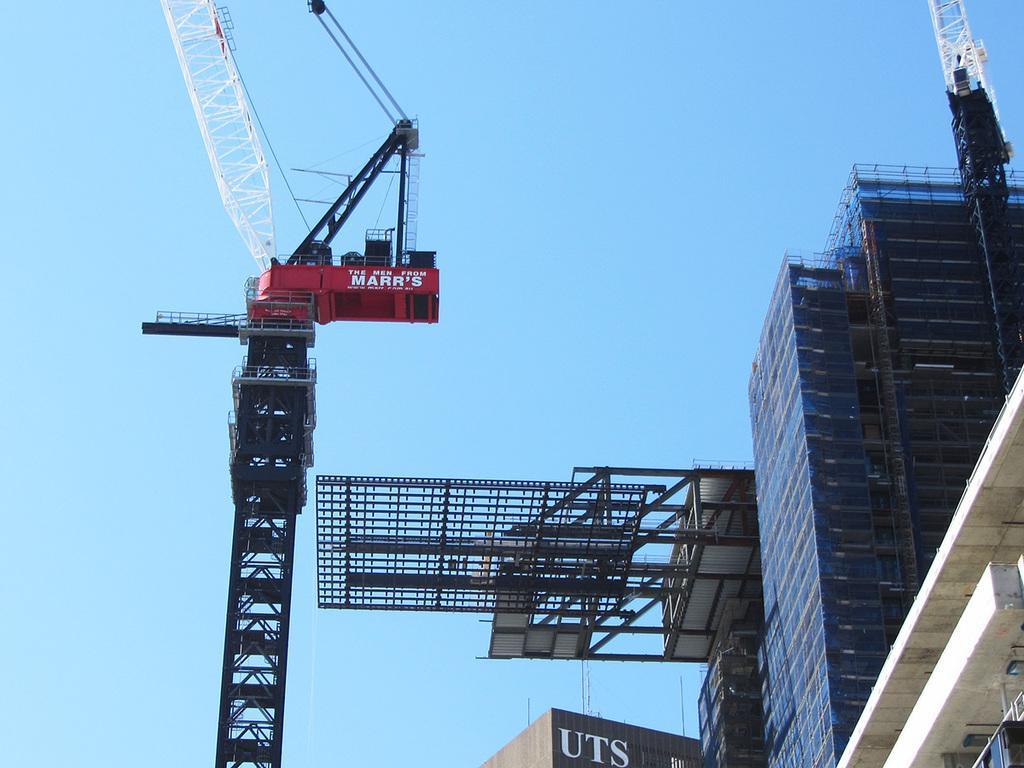Describe this image in one or two sentences. In the image we can see a crane, buildings, text and a pale blue sky. 